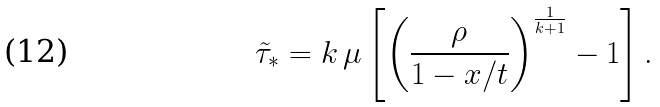Convert formula to latex. <formula><loc_0><loc_0><loc_500><loc_500>\tilde { \tau } _ { * } = k \, \mu \left [ \left ( \frac { \rho } { 1 - x / t } \right ) ^ { \frac { 1 } { k + 1 } } - 1 \right ] .</formula> 